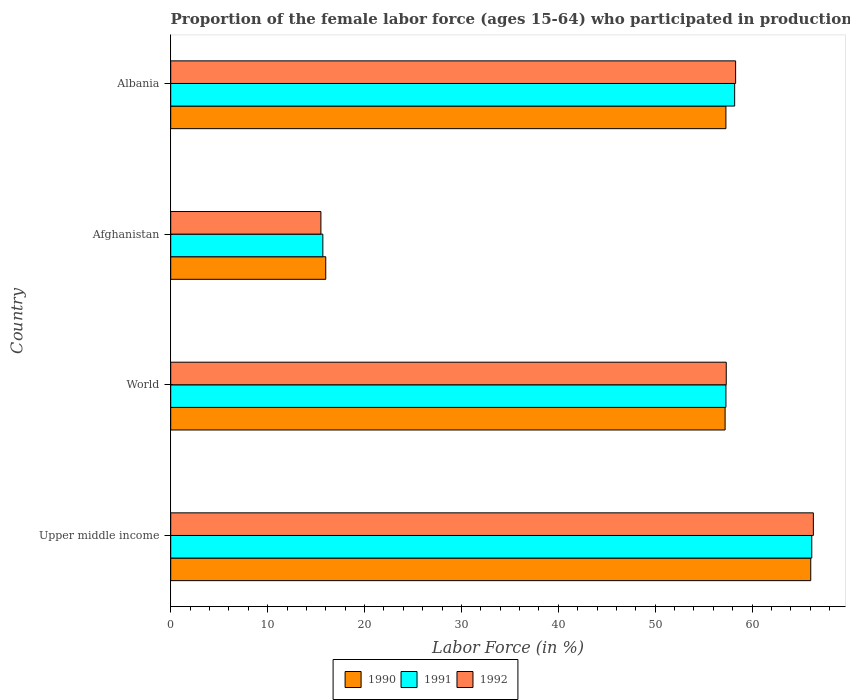Are the number of bars on each tick of the Y-axis equal?
Give a very brief answer. Yes. How many bars are there on the 1st tick from the top?
Offer a terse response. 3. What is the label of the 4th group of bars from the top?
Give a very brief answer. Upper middle income. Across all countries, what is the maximum proportion of the female labor force who participated in production in 1991?
Give a very brief answer. 66.16. Across all countries, what is the minimum proportion of the female labor force who participated in production in 1990?
Your response must be concise. 16. In which country was the proportion of the female labor force who participated in production in 1992 maximum?
Offer a very short reply. Upper middle income. In which country was the proportion of the female labor force who participated in production in 1991 minimum?
Offer a very short reply. Afghanistan. What is the total proportion of the female labor force who participated in production in 1992 in the graph?
Provide a short and direct response. 197.46. What is the difference between the proportion of the female labor force who participated in production in 1990 in Afghanistan and that in Upper middle income?
Your response must be concise. -50.05. What is the difference between the proportion of the female labor force who participated in production in 1991 in Upper middle income and the proportion of the female labor force who participated in production in 1992 in World?
Your answer should be very brief. 8.83. What is the average proportion of the female labor force who participated in production in 1992 per country?
Ensure brevity in your answer.  49.36. What is the difference between the proportion of the female labor force who participated in production in 1992 and proportion of the female labor force who participated in production in 1991 in Albania?
Make the answer very short. 0.1. In how many countries, is the proportion of the female labor force who participated in production in 1991 greater than 36 %?
Your response must be concise. 3. What is the ratio of the proportion of the female labor force who participated in production in 1990 in Afghanistan to that in Upper middle income?
Your answer should be compact. 0.24. Is the proportion of the female labor force who participated in production in 1991 in Afghanistan less than that in Albania?
Keep it short and to the point. Yes. What is the difference between the highest and the second highest proportion of the female labor force who participated in production in 1990?
Your answer should be very brief. 8.75. What is the difference between the highest and the lowest proportion of the female labor force who participated in production in 1991?
Keep it short and to the point. 50.46. In how many countries, is the proportion of the female labor force who participated in production in 1992 greater than the average proportion of the female labor force who participated in production in 1992 taken over all countries?
Your answer should be very brief. 3. Is the sum of the proportion of the female labor force who participated in production in 1992 in Afghanistan and Albania greater than the maximum proportion of the female labor force who participated in production in 1991 across all countries?
Your answer should be compact. Yes. What does the 2nd bar from the top in Albania represents?
Your response must be concise. 1991. What does the 1st bar from the bottom in Upper middle income represents?
Provide a succinct answer. 1990. What is the difference between two consecutive major ticks on the X-axis?
Offer a very short reply. 10. Does the graph contain any zero values?
Give a very brief answer. No. Where does the legend appear in the graph?
Keep it short and to the point. Bottom center. How are the legend labels stacked?
Make the answer very short. Horizontal. What is the title of the graph?
Provide a short and direct response. Proportion of the female labor force (ages 15-64) who participated in production. Does "2012" appear as one of the legend labels in the graph?
Give a very brief answer. No. What is the Labor Force (in %) in 1990 in Upper middle income?
Provide a succinct answer. 66.05. What is the Labor Force (in %) in 1991 in Upper middle income?
Keep it short and to the point. 66.16. What is the Labor Force (in %) in 1992 in Upper middle income?
Make the answer very short. 66.32. What is the Labor Force (in %) of 1990 in World?
Make the answer very short. 57.21. What is the Labor Force (in %) of 1991 in World?
Make the answer very short. 57.3. What is the Labor Force (in %) in 1992 in World?
Make the answer very short. 57.33. What is the Labor Force (in %) in 1990 in Afghanistan?
Make the answer very short. 16. What is the Labor Force (in %) in 1991 in Afghanistan?
Ensure brevity in your answer.  15.7. What is the Labor Force (in %) in 1992 in Afghanistan?
Your answer should be very brief. 15.5. What is the Labor Force (in %) of 1990 in Albania?
Your answer should be very brief. 57.3. What is the Labor Force (in %) of 1991 in Albania?
Give a very brief answer. 58.2. What is the Labor Force (in %) of 1992 in Albania?
Offer a very short reply. 58.3. Across all countries, what is the maximum Labor Force (in %) of 1990?
Your answer should be very brief. 66.05. Across all countries, what is the maximum Labor Force (in %) in 1991?
Offer a very short reply. 66.16. Across all countries, what is the maximum Labor Force (in %) of 1992?
Ensure brevity in your answer.  66.32. Across all countries, what is the minimum Labor Force (in %) in 1991?
Your response must be concise. 15.7. What is the total Labor Force (in %) in 1990 in the graph?
Your response must be concise. 196.57. What is the total Labor Force (in %) in 1991 in the graph?
Keep it short and to the point. 197.36. What is the total Labor Force (in %) of 1992 in the graph?
Ensure brevity in your answer.  197.46. What is the difference between the Labor Force (in %) in 1990 in Upper middle income and that in World?
Provide a succinct answer. 8.84. What is the difference between the Labor Force (in %) of 1991 in Upper middle income and that in World?
Make the answer very short. 8.86. What is the difference between the Labor Force (in %) of 1992 in Upper middle income and that in World?
Make the answer very short. 8.99. What is the difference between the Labor Force (in %) of 1990 in Upper middle income and that in Afghanistan?
Provide a succinct answer. 50.05. What is the difference between the Labor Force (in %) of 1991 in Upper middle income and that in Afghanistan?
Offer a terse response. 50.46. What is the difference between the Labor Force (in %) of 1992 in Upper middle income and that in Afghanistan?
Ensure brevity in your answer.  50.82. What is the difference between the Labor Force (in %) of 1990 in Upper middle income and that in Albania?
Ensure brevity in your answer.  8.75. What is the difference between the Labor Force (in %) in 1991 in Upper middle income and that in Albania?
Provide a short and direct response. 7.96. What is the difference between the Labor Force (in %) of 1992 in Upper middle income and that in Albania?
Offer a terse response. 8.02. What is the difference between the Labor Force (in %) in 1990 in World and that in Afghanistan?
Keep it short and to the point. 41.21. What is the difference between the Labor Force (in %) of 1991 in World and that in Afghanistan?
Offer a very short reply. 41.6. What is the difference between the Labor Force (in %) of 1992 in World and that in Afghanistan?
Your response must be concise. 41.83. What is the difference between the Labor Force (in %) in 1990 in World and that in Albania?
Ensure brevity in your answer.  -0.09. What is the difference between the Labor Force (in %) of 1991 in World and that in Albania?
Offer a very short reply. -0.9. What is the difference between the Labor Force (in %) in 1992 in World and that in Albania?
Your response must be concise. -0.97. What is the difference between the Labor Force (in %) in 1990 in Afghanistan and that in Albania?
Give a very brief answer. -41.3. What is the difference between the Labor Force (in %) in 1991 in Afghanistan and that in Albania?
Ensure brevity in your answer.  -42.5. What is the difference between the Labor Force (in %) of 1992 in Afghanistan and that in Albania?
Your response must be concise. -42.8. What is the difference between the Labor Force (in %) of 1990 in Upper middle income and the Labor Force (in %) of 1991 in World?
Offer a very short reply. 8.75. What is the difference between the Labor Force (in %) in 1990 in Upper middle income and the Labor Force (in %) in 1992 in World?
Your response must be concise. 8.72. What is the difference between the Labor Force (in %) in 1991 in Upper middle income and the Labor Force (in %) in 1992 in World?
Give a very brief answer. 8.83. What is the difference between the Labor Force (in %) of 1990 in Upper middle income and the Labor Force (in %) of 1991 in Afghanistan?
Keep it short and to the point. 50.35. What is the difference between the Labor Force (in %) in 1990 in Upper middle income and the Labor Force (in %) in 1992 in Afghanistan?
Provide a short and direct response. 50.55. What is the difference between the Labor Force (in %) of 1991 in Upper middle income and the Labor Force (in %) of 1992 in Afghanistan?
Make the answer very short. 50.66. What is the difference between the Labor Force (in %) of 1990 in Upper middle income and the Labor Force (in %) of 1991 in Albania?
Offer a terse response. 7.85. What is the difference between the Labor Force (in %) in 1990 in Upper middle income and the Labor Force (in %) in 1992 in Albania?
Your answer should be very brief. 7.75. What is the difference between the Labor Force (in %) of 1991 in Upper middle income and the Labor Force (in %) of 1992 in Albania?
Give a very brief answer. 7.86. What is the difference between the Labor Force (in %) of 1990 in World and the Labor Force (in %) of 1991 in Afghanistan?
Keep it short and to the point. 41.51. What is the difference between the Labor Force (in %) in 1990 in World and the Labor Force (in %) in 1992 in Afghanistan?
Ensure brevity in your answer.  41.71. What is the difference between the Labor Force (in %) of 1991 in World and the Labor Force (in %) of 1992 in Afghanistan?
Provide a short and direct response. 41.8. What is the difference between the Labor Force (in %) in 1990 in World and the Labor Force (in %) in 1991 in Albania?
Make the answer very short. -0.99. What is the difference between the Labor Force (in %) of 1990 in World and the Labor Force (in %) of 1992 in Albania?
Your answer should be compact. -1.09. What is the difference between the Labor Force (in %) in 1991 in World and the Labor Force (in %) in 1992 in Albania?
Provide a short and direct response. -1. What is the difference between the Labor Force (in %) in 1990 in Afghanistan and the Labor Force (in %) in 1991 in Albania?
Ensure brevity in your answer.  -42.2. What is the difference between the Labor Force (in %) in 1990 in Afghanistan and the Labor Force (in %) in 1992 in Albania?
Offer a terse response. -42.3. What is the difference between the Labor Force (in %) in 1991 in Afghanistan and the Labor Force (in %) in 1992 in Albania?
Give a very brief answer. -42.6. What is the average Labor Force (in %) in 1990 per country?
Make the answer very short. 49.14. What is the average Labor Force (in %) of 1991 per country?
Provide a succinct answer. 49.34. What is the average Labor Force (in %) of 1992 per country?
Keep it short and to the point. 49.36. What is the difference between the Labor Force (in %) of 1990 and Labor Force (in %) of 1991 in Upper middle income?
Keep it short and to the point. -0.11. What is the difference between the Labor Force (in %) in 1990 and Labor Force (in %) in 1992 in Upper middle income?
Provide a short and direct response. -0.27. What is the difference between the Labor Force (in %) of 1991 and Labor Force (in %) of 1992 in Upper middle income?
Provide a short and direct response. -0.16. What is the difference between the Labor Force (in %) in 1990 and Labor Force (in %) in 1991 in World?
Your answer should be very brief. -0.09. What is the difference between the Labor Force (in %) in 1990 and Labor Force (in %) in 1992 in World?
Your answer should be very brief. -0.12. What is the difference between the Labor Force (in %) in 1991 and Labor Force (in %) in 1992 in World?
Your answer should be compact. -0.03. What is the difference between the Labor Force (in %) of 1990 and Labor Force (in %) of 1991 in Afghanistan?
Give a very brief answer. 0.3. What is the difference between the Labor Force (in %) in 1991 and Labor Force (in %) in 1992 in Afghanistan?
Your response must be concise. 0.2. What is the difference between the Labor Force (in %) in 1990 and Labor Force (in %) in 1991 in Albania?
Your answer should be compact. -0.9. What is the difference between the Labor Force (in %) in 1990 and Labor Force (in %) in 1992 in Albania?
Offer a very short reply. -1. What is the difference between the Labor Force (in %) in 1991 and Labor Force (in %) in 1992 in Albania?
Offer a very short reply. -0.1. What is the ratio of the Labor Force (in %) in 1990 in Upper middle income to that in World?
Your response must be concise. 1.15. What is the ratio of the Labor Force (in %) in 1991 in Upper middle income to that in World?
Your answer should be compact. 1.15. What is the ratio of the Labor Force (in %) in 1992 in Upper middle income to that in World?
Your answer should be very brief. 1.16. What is the ratio of the Labor Force (in %) in 1990 in Upper middle income to that in Afghanistan?
Provide a succinct answer. 4.13. What is the ratio of the Labor Force (in %) in 1991 in Upper middle income to that in Afghanistan?
Give a very brief answer. 4.21. What is the ratio of the Labor Force (in %) of 1992 in Upper middle income to that in Afghanistan?
Offer a very short reply. 4.28. What is the ratio of the Labor Force (in %) of 1990 in Upper middle income to that in Albania?
Ensure brevity in your answer.  1.15. What is the ratio of the Labor Force (in %) in 1991 in Upper middle income to that in Albania?
Keep it short and to the point. 1.14. What is the ratio of the Labor Force (in %) in 1992 in Upper middle income to that in Albania?
Keep it short and to the point. 1.14. What is the ratio of the Labor Force (in %) of 1990 in World to that in Afghanistan?
Provide a short and direct response. 3.58. What is the ratio of the Labor Force (in %) in 1991 in World to that in Afghanistan?
Your answer should be very brief. 3.65. What is the ratio of the Labor Force (in %) of 1992 in World to that in Afghanistan?
Your response must be concise. 3.7. What is the ratio of the Labor Force (in %) in 1990 in World to that in Albania?
Keep it short and to the point. 1. What is the ratio of the Labor Force (in %) of 1991 in World to that in Albania?
Offer a very short reply. 0.98. What is the ratio of the Labor Force (in %) in 1992 in World to that in Albania?
Provide a short and direct response. 0.98. What is the ratio of the Labor Force (in %) in 1990 in Afghanistan to that in Albania?
Offer a terse response. 0.28. What is the ratio of the Labor Force (in %) in 1991 in Afghanistan to that in Albania?
Offer a very short reply. 0.27. What is the ratio of the Labor Force (in %) of 1992 in Afghanistan to that in Albania?
Provide a short and direct response. 0.27. What is the difference between the highest and the second highest Labor Force (in %) in 1990?
Give a very brief answer. 8.75. What is the difference between the highest and the second highest Labor Force (in %) of 1991?
Your answer should be compact. 7.96. What is the difference between the highest and the second highest Labor Force (in %) of 1992?
Your response must be concise. 8.02. What is the difference between the highest and the lowest Labor Force (in %) in 1990?
Your answer should be very brief. 50.05. What is the difference between the highest and the lowest Labor Force (in %) of 1991?
Provide a succinct answer. 50.46. What is the difference between the highest and the lowest Labor Force (in %) of 1992?
Ensure brevity in your answer.  50.82. 